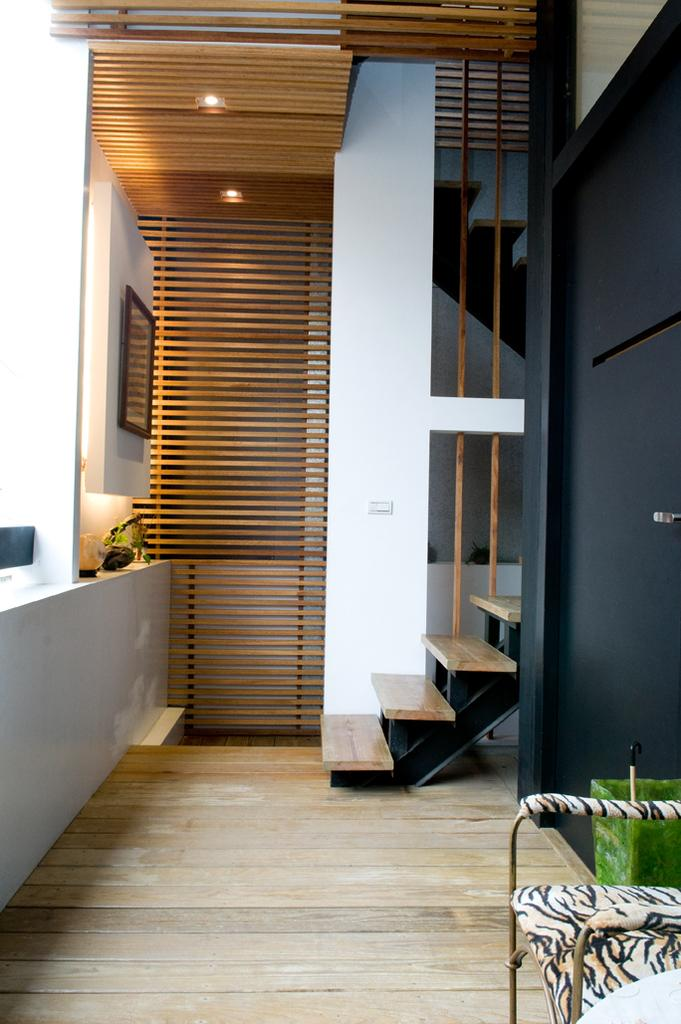What type of location is depicted in the image? The image shows an inside view of a building. What type of furniture is visible in the image? There is a chair in the image. What architectural feature is present in the image? There is a door in the image. What is a functional element in the image? There are stairs in the image. What type of decoration is on the wall in the image? There is a photo frame on the wall in the image. What color is the mist surrounding the cat in the image? There is no mist or cat present in the image. 